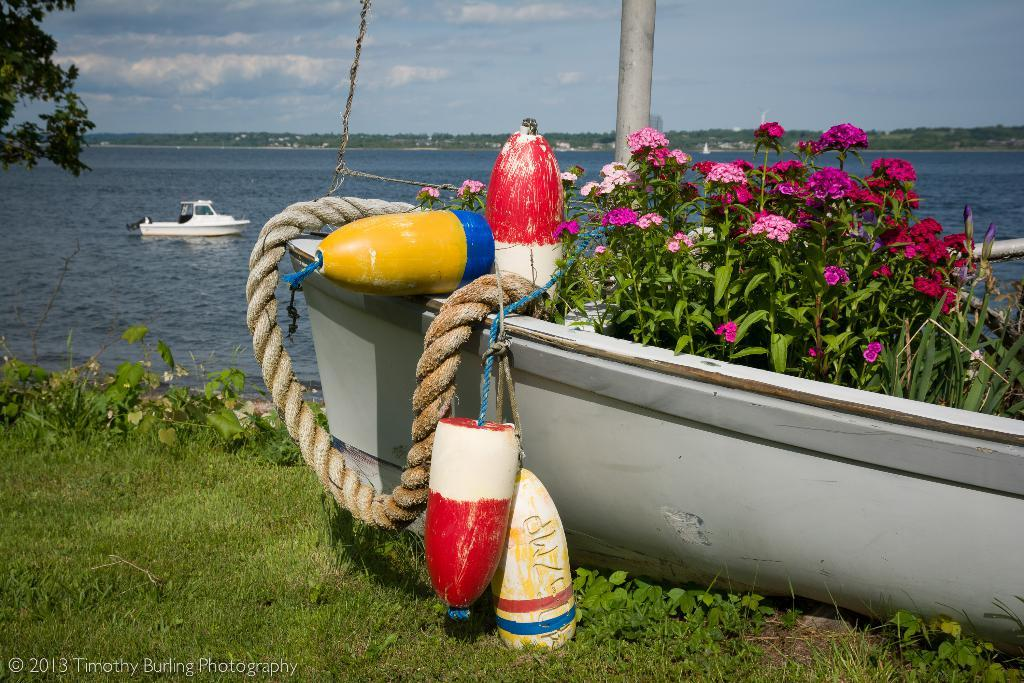What type of vegetation can be seen in the image? There is grass, plants, and flowers visible in the image. What objects are related to water in the image? There are boats and water visible in the image. What natural elements are present in the sky? There are clouds visible in the sky. What is the tree in the image like? There is a tree in the image. What can be used for tying or securing objects in the image? There is a rope in the image. What type of chalk is being used to draw on the boat in the image? There is no chalk or drawing activity present in the image. What type of quill is being used to write on the tree in the image? There is no quill or writing activity present in the image. 